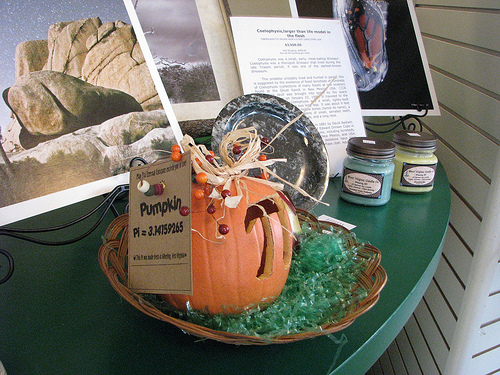<image>
Is there a blue jar behind the yellow jar? No. The blue jar is not behind the yellow jar. From this viewpoint, the blue jar appears to be positioned elsewhere in the scene. 